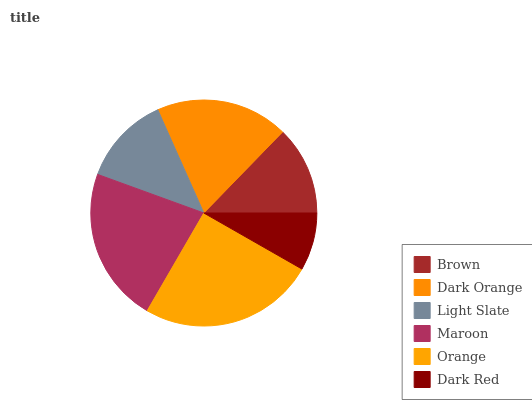Is Dark Red the minimum?
Answer yes or no. Yes. Is Orange the maximum?
Answer yes or no. Yes. Is Dark Orange the minimum?
Answer yes or no. No. Is Dark Orange the maximum?
Answer yes or no. No. Is Dark Orange greater than Brown?
Answer yes or no. Yes. Is Brown less than Dark Orange?
Answer yes or no. Yes. Is Brown greater than Dark Orange?
Answer yes or no. No. Is Dark Orange less than Brown?
Answer yes or no. No. Is Dark Orange the high median?
Answer yes or no. Yes. Is Light Slate the low median?
Answer yes or no. Yes. Is Maroon the high median?
Answer yes or no. No. Is Maroon the low median?
Answer yes or no. No. 